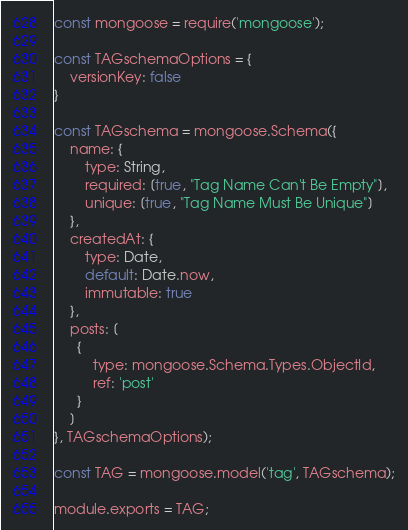<code> <loc_0><loc_0><loc_500><loc_500><_JavaScript_>const mongoose = require('mongoose');

const TAGschemaOptions = {
	versionKey: false
}

const TAGschema = mongoose.Schema({
    name: {
        type: String,
        required: [true, "Tag Name Can't Be Empty"],
        unique: [true, "Tag Name Must Be Unique"]
    },
    createdAt: {
        type: Date,
        default: Date.now,
        immutable: true
    },
    posts: [
      {
          type: mongoose.Schema.Types.ObjectId,
          ref: 'post'
      }
    ]
}, TAGschemaOptions);

const TAG = mongoose.model('tag', TAGschema);

module.exports = TAG;</code> 